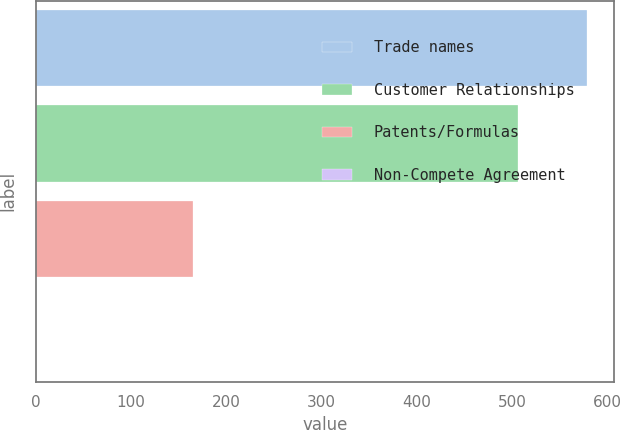Convert chart to OTSL. <chart><loc_0><loc_0><loc_500><loc_500><bar_chart><fcel>Trade names<fcel>Customer Relationships<fcel>Patents/Formulas<fcel>Non-Compete Agreement<nl><fcel>578.6<fcel>506.3<fcel>165.4<fcel>0.4<nl></chart> 